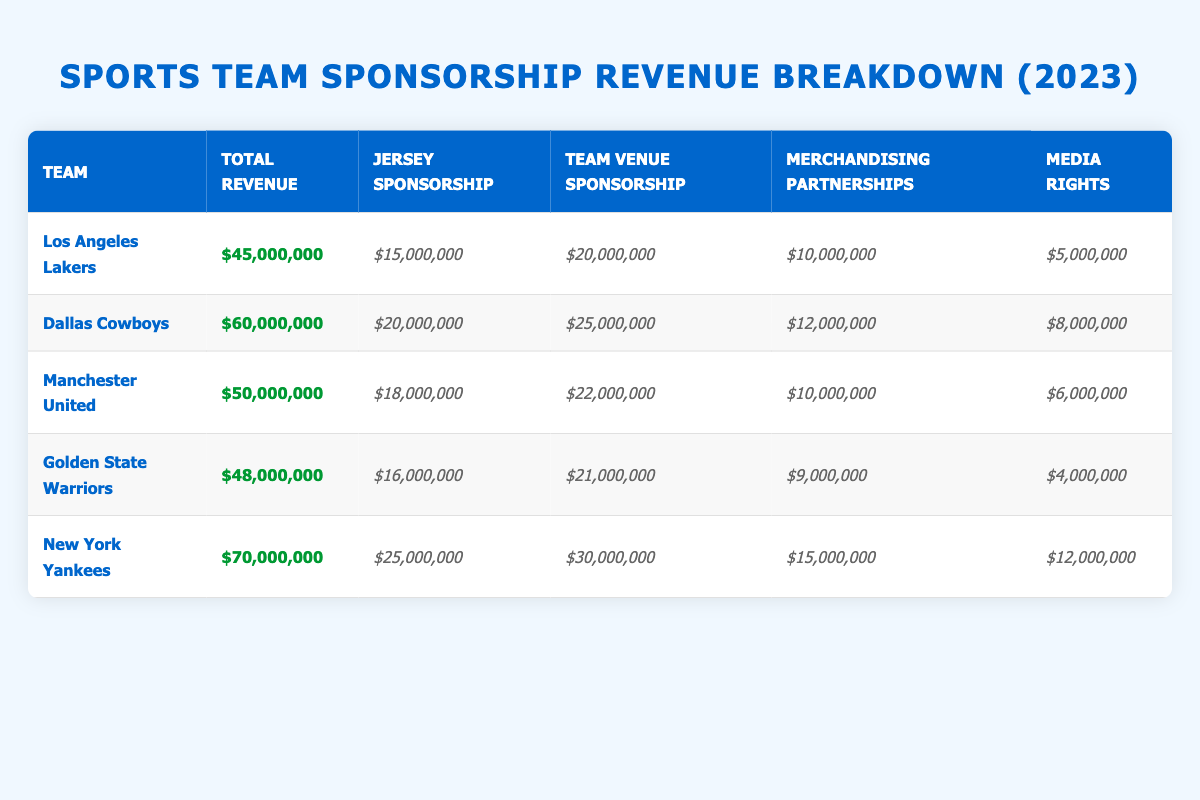What is the total revenue for the New York Yankees in 2023? The total revenue for the New York Yankees is listed directly in the table under the "Total Revenue" column, which is $70,000,000.
Answer: $70,000,000 Which team has the highest jersey sponsorship revenue? By comparing the "Jersey Sponsorship" values in the table, the New York Yankees has the highest jersey sponsorship revenue of $25,000,000.
Answer: New York Yankees What is the combined media rights revenue for the Los Angeles Lakers and the Golden State Warriors? The media rights revenue for the Los Angeles Lakers is $5,000,000 and for the Golden State Warriors is $4,000,000. Adding these together gives $5,000,000 + $4,000,000 = $9,000,000.
Answer: $9,000,000 Is Manchester United's total revenue greater than that of the Los Angeles Lakers? The total revenue for Manchester United is $50,000,000, while for the Los Angeles Lakers it is $45,000,000. Since $50,000,000 is greater than $45,000,000, the statement is true.
Answer: Yes What percentage of the total revenue for the Dallas Cowboys comes from jersey sponsorship? The total revenue for the Dallas Cowboys is $60,000,000, and the jersey sponsorship revenue is $20,000,000. To find the percentage, divide $20,000,000 by $60,000,000 and multiply by 100: ($20,000,000 / $60,000,000) * 100 = 33.33%.
Answer: 33.33% Which team has the largest amount of revenue coming from team venue sponsorship? The "Team Venue Sponsorship" revenues are compared, and the Dallas Cowboys have the largest amount at $25,000,000, higher than other teams listed.
Answer: Dallas Cowboys What is the average merchandising partnerships revenue across all teams? The total merchandising partnerships revenue for all teams is $10,000,000 (Lakers) + $12,000,000 (Cowboys) + $10,000,000 (Manchester United) + $9,000,000 (Warriors) + $15,000,000 (Yankees) = $56,000,000. Since there are 5 teams, the average is $56,000,000 / 5 = $11,200,000.
Answer: $11,200,000 Do any teams generate more than $20,000,000 from media rights? The media rights revenues are $5,000,000 (Lakers), $8,000,000 (Cowboys), $6,000,000 (Manchester United), $4,000,000 (Warriors), and $12,000,000 (Yankees). None of these values exceed $20,000,000.
Answer: No What is the difference in total revenue between the New York Yankees and the Golden State Warriors? The total revenue for the New York Yankees is $70,000,000, while the Golden State Warriors have a total revenue of $48,000,000. The difference is $70,000,000 - $48,000,000 = $22,000,000.
Answer: $22,000,000 